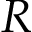Convert formula to latex. <formula><loc_0><loc_0><loc_500><loc_500>R</formula> 